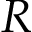Convert formula to latex. <formula><loc_0><loc_0><loc_500><loc_500>R</formula> 